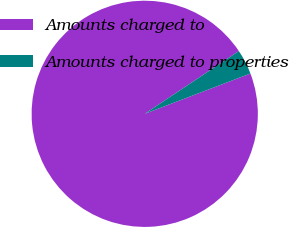Convert chart to OTSL. <chart><loc_0><loc_0><loc_500><loc_500><pie_chart><fcel>Amounts charged to<fcel>Amounts charged to properties<nl><fcel>96.44%<fcel>3.56%<nl></chart> 